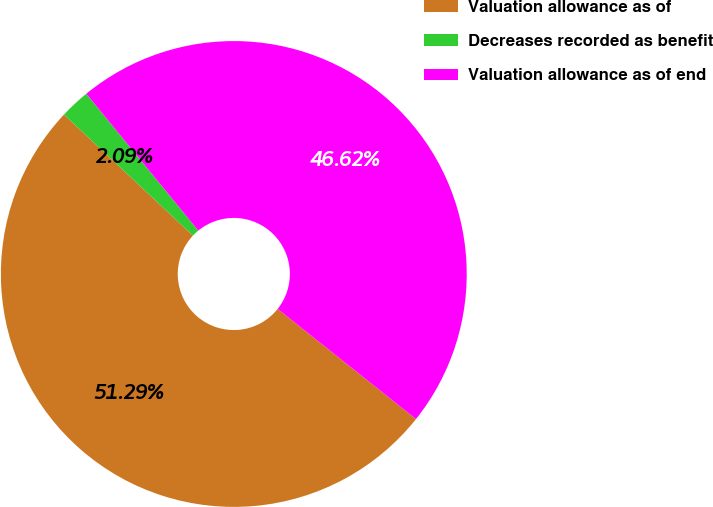Convert chart to OTSL. <chart><loc_0><loc_0><loc_500><loc_500><pie_chart><fcel>Valuation allowance as of<fcel>Decreases recorded as benefit<fcel>Valuation allowance as of end<nl><fcel>51.29%<fcel>2.09%<fcel>46.62%<nl></chart> 